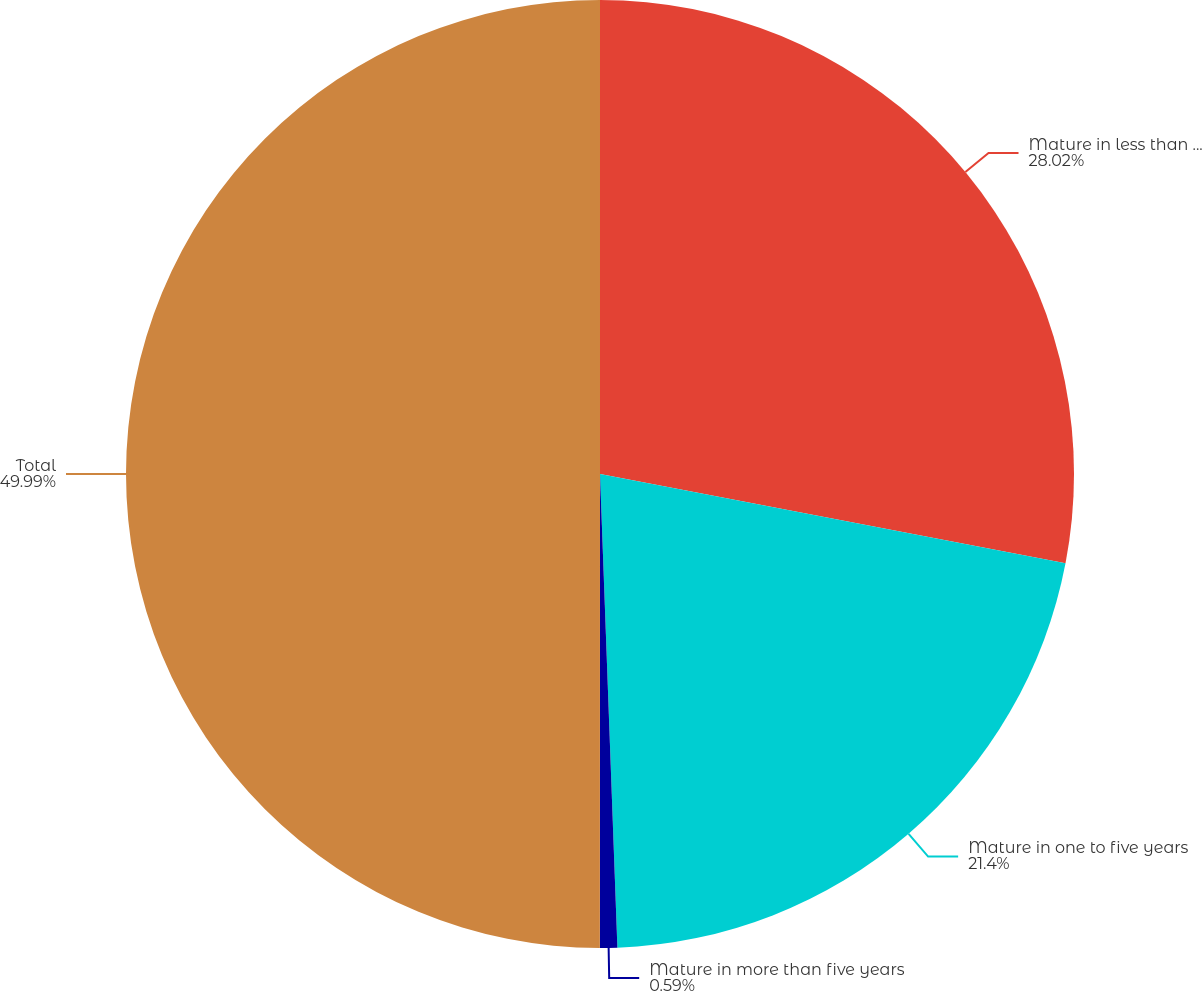Convert chart. <chart><loc_0><loc_0><loc_500><loc_500><pie_chart><fcel>Mature in less than one year<fcel>Mature in one to five years<fcel>Mature in more than five years<fcel>Total<nl><fcel>28.02%<fcel>21.4%<fcel>0.59%<fcel>50.0%<nl></chart> 